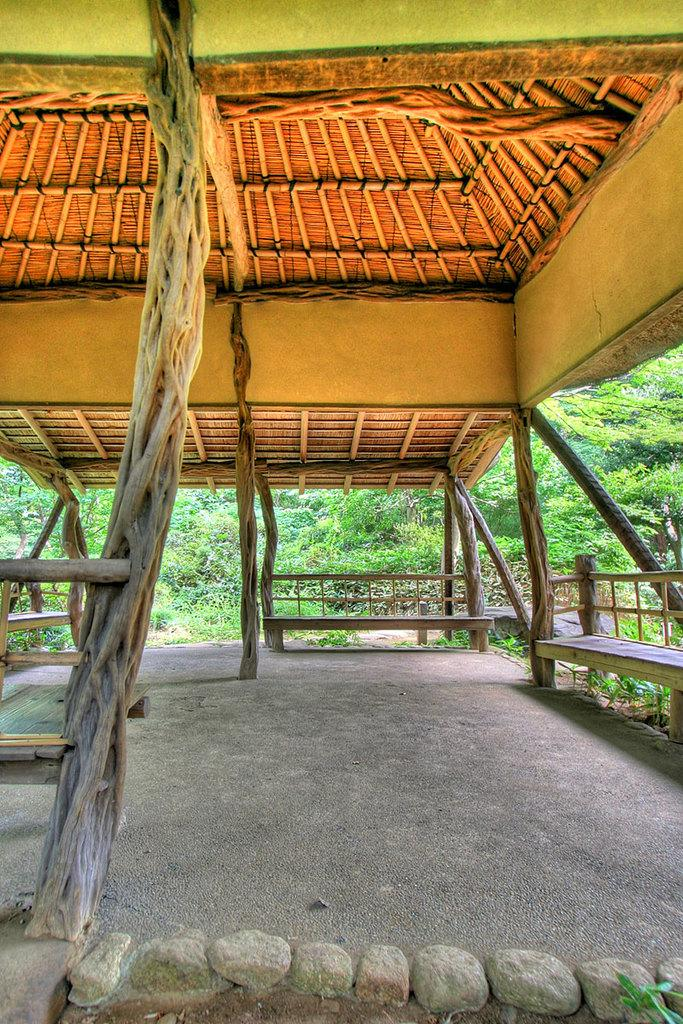What structure is located in the foreground of the image? There is a shelter in the foreground of the image. What type of material is used for the poles in the foreground? The poles in the foreground are made of wood. What type of seating is available in the foreground? There are benches in the foreground of the image. What can be seen at the bottom of the image? There are stones at the bottom of the image. What type of vegetation is visible in the background? There are trees in the background of the image. What type of headwear is the person wearing in the image? There are no people or headwear visible in the image. What question is being asked by the person in the image? There are no people or questions present in the image. 